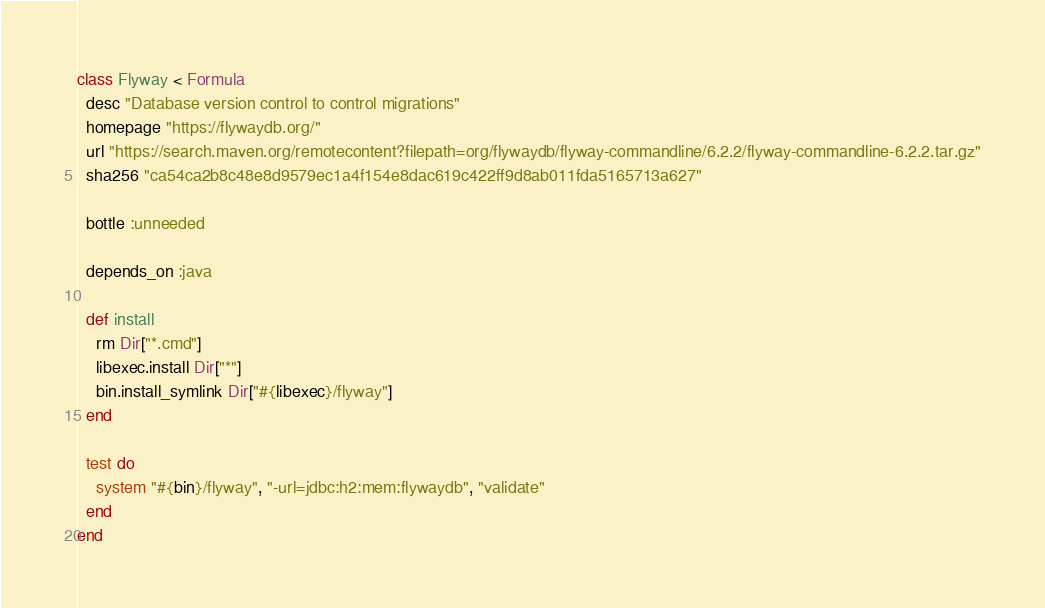Convert code to text. <code><loc_0><loc_0><loc_500><loc_500><_Ruby_>class Flyway < Formula
  desc "Database version control to control migrations"
  homepage "https://flywaydb.org/"
  url "https://search.maven.org/remotecontent?filepath=org/flywaydb/flyway-commandline/6.2.2/flyway-commandline-6.2.2.tar.gz"
  sha256 "ca54ca2b8c48e8d9579ec1a4f154e8dac619c422ff9d8ab011fda5165713a627"

  bottle :unneeded

  depends_on :java

  def install
    rm Dir["*.cmd"]
    libexec.install Dir["*"]
    bin.install_symlink Dir["#{libexec}/flyway"]
  end

  test do
    system "#{bin}/flyway", "-url=jdbc:h2:mem:flywaydb", "validate"
  end
end
</code> 